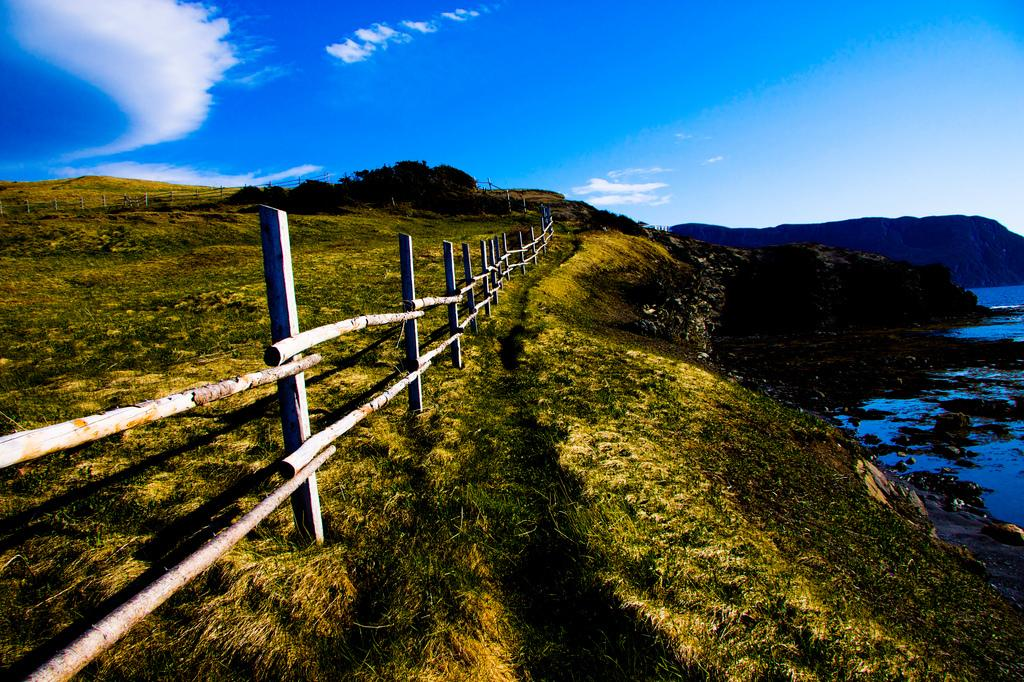What type of vegetation can be seen in the image? There is grass in the image. What type of barrier is present in the image? There is a wooden fence in the image. What can be seen besides the grass and fence in the image? There is water visible in the image. What is visible in the background of the image? There is a hill and sky visible in the background of the image. What is present in the sky in the image? There are clouds in the sky. What type of card is being used to start the engine in the image? There is no card or engine present in the image. 